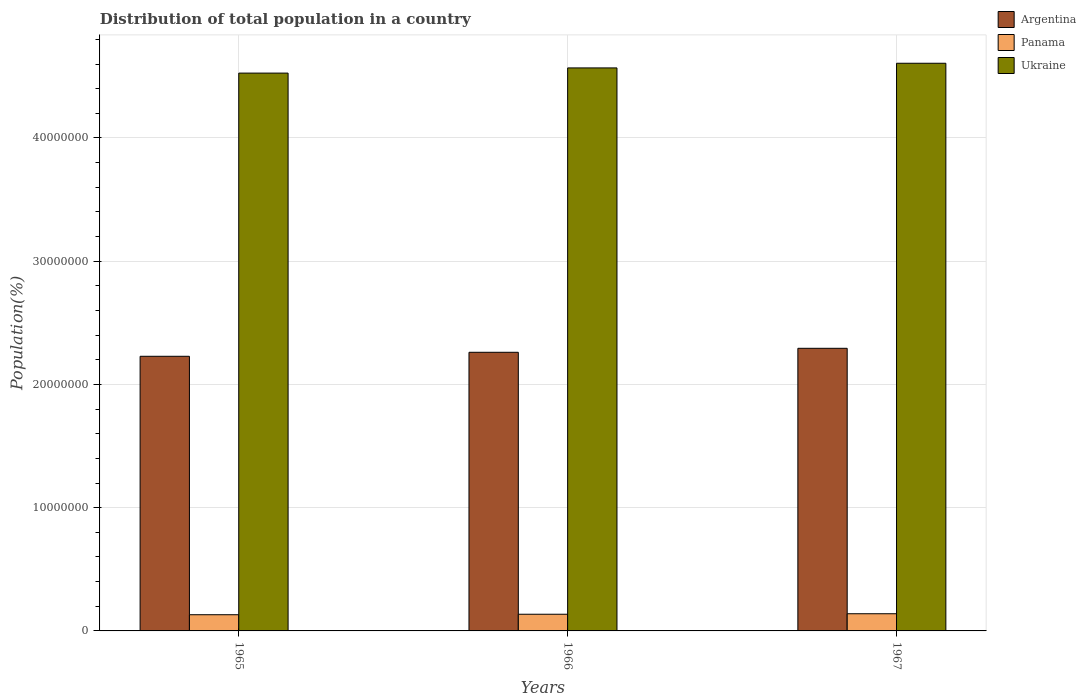How many groups of bars are there?
Provide a succinct answer. 3. How many bars are there on the 2nd tick from the left?
Keep it short and to the point. 3. What is the label of the 1st group of bars from the left?
Your answer should be compact. 1965. What is the population of in Ukraine in 1966?
Give a very brief answer. 4.57e+07. Across all years, what is the maximum population of in Argentina?
Your response must be concise. 2.29e+07. Across all years, what is the minimum population of in Panama?
Offer a very short reply. 1.31e+06. In which year was the population of in Ukraine maximum?
Give a very brief answer. 1967. In which year was the population of in Argentina minimum?
Your answer should be very brief. 1965. What is the total population of in Ukraine in the graph?
Offer a terse response. 1.37e+08. What is the difference between the population of in Ukraine in 1966 and that in 1967?
Give a very brief answer. -3.78e+05. What is the difference between the population of in Ukraine in 1965 and the population of in Panama in 1967?
Your response must be concise. 4.39e+07. What is the average population of in Panama per year?
Give a very brief answer. 1.35e+06. In the year 1967, what is the difference between the population of in Argentina and population of in Panama?
Your response must be concise. 2.15e+07. What is the ratio of the population of in Panama in 1966 to that in 1967?
Provide a short and direct response. 0.97. What is the difference between the highest and the second highest population of in Panama?
Provide a short and direct response. 4.00e+04. What is the difference between the highest and the lowest population of in Panama?
Keep it short and to the point. 7.92e+04. In how many years, is the population of in Argentina greater than the average population of in Argentina taken over all years?
Ensure brevity in your answer.  2. Is the sum of the population of in Argentina in 1966 and 1967 greater than the maximum population of in Panama across all years?
Provide a succinct answer. Yes. What does the 3rd bar from the right in 1967 represents?
Provide a short and direct response. Argentina. How many bars are there?
Your response must be concise. 9. Are all the bars in the graph horizontal?
Give a very brief answer. No. What is the difference between two consecutive major ticks on the Y-axis?
Offer a very short reply. 1.00e+07. Are the values on the major ticks of Y-axis written in scientific E-notation?
Keep it short and to the point. No. Does the graph contain any zero values?
Provide a succinct answer. No. Where does the legend appear in the graph?
Ensure brevity in your answer.  Top right. How many legend labels are there?
Provide a succinct answer. 3. How are the legend labels stacked?
Offer a terse response. Vertical. What is the title of the graph?
Your answer should be compact. Distribution of total population in a country. Does "Oman" appear as one of the legend labels in the graph?
Your answer should be very brief. No. What is the label or title of the X-axis?
Offer a very short reply. Years. What is the label or title of the Y-axis?
Offer a terse response. Population(%). What is the Population(%) in Argentina in 1965?
Your answer should be very brief. 2.23e+07. What is the Population(%) in Panama in 1965?
Provide a succinct answer. 1.31e+06. What is the Population(%) in Ukraine in 1965?
Provide a short and direct response. 4.53e+07. What is the Population(%) in Argentina in 1966?
Offer a very short reply. 2.26e+07. What is the Population(%) of Panama in 1966?
Ensure brevity in your answer.  1.35e+06. What is the Population(%) in Ukraine in 1966?
Your answer should be very brief. 4.57e+07. What is the Population(%) of Argentina in 1967?
Your answer should be very brief. 2.29e+07. What is the Population(%) of Panama in 1967?
Give a very brief answer. 1.39e+06. What is the Population(%) in Ukraine in 1967?
Your answer should be compact. 4.61e+07. Across all years, what is the maximum Population(%) in Argentina?
Provide a short and direct response. 2.29e+07. Across all years, what is the maximum Population(%) in Panama?
Ensure brevity in your answer.  1.39e+06. Across all years, what is the maximum Population(%) in Ukraine?
Offer a terse response. 4.61e+07. Across all years, what is the minimum Population(%) in Argentina?
Make the answer very short. 2.23e+07. Across all years, what is the minimum Population(%) of Panama?
Ensure brevity in your answer.  1.31e+06. Across all years, what is the minimum Population(%) of Ukraine?
Offer a very short reply. 4.53e+07. What is the total Population(%) in Argentina in the graph?
Offer a terse response. 6.78e+07. What is the total Population(%) of Panama in the graph?
Make the answer very short. 4.06e+06. What is the total Population(%) in Ukraine in the graph?
Provide a succinct answer. 1.37e+08. What is the difference between the Population(%) in Argentina in 1965 and that in 1966?
Offer a terse response. -3.25e+05. What is the difference between the Population(%) in Panama in 1965 and that in 1966?
Ensure brevity in your answer.  -3.92e+04. What is the difference between the Population(%) of Ukraine in 1965 and that in 1966?
Offer a terse response. -4.20e+05. What is the difference between the Population(%) of Argentina in 1965 and that in 1967?
Ensure brevity in your answer.  -6.49e+05. What is the difference between the Population(%) in Panama in 1965 and that in 1967?
Provide a succinct answer. -7.92e+04. What is the difference between the Population(%) of Ukraine in 1965 and that in 1967?
Your response must be concise. -7.99e+05. What is the difference between the Population(%) of Argentina in 1966 and that in 1967?
Your answer should be very brief. -3.23e+05. What is the difference between the Population(%) in Panama in 1966 and that in 1967?
Your response must be concise. -4.00e+04. What is the difference between the Population(%) in Ukraine in 1966 and that in 1967?
Give a very brief answer. -3.78e+05. What is the difference between the Population(%) in Argentina in 1965 and the Population(%) in Panama in 1966?
Your response must be concise. 2.09e+07. What is the difference between the Population(%) of Argentina in 1965 and the Population(%) of Ukraine in 1966?
Provide a succinct answer. -2.34e+07. What is the difference between the Population(%) in Panama in 1965 and the Population(%) in Ukraine in 1966?
Provide a succinct answer. -4.44e+07. What is the difference between the Population(%) in Argentina in 1965 and the Population(%) in Panama in 1967?
Provide a succinct answer. 2.09e+07. What is the difference between the Population(%) in Argentina in 1965 and the Population(%) in Ukraine in 1967?
Ensure brevity in your answer.  -2.38e+07. What is the difference between the Population(%) of Panama in 1965 and the Population(%) of Ukraine in 1967?
Give a very brief answer. -4.47e+07. What is the difference between the Population(%) of Argentina in 1966 and the Population(%) of Panama in 1967?
Ensure brevity in your answer.  2.12e+07. What is the difference between the Population(%) in Argentina in 1966 and the Population(%) in Ukraine in 1967?
Ensure brevity in your answer.  -2.35e+07. What is the difference between the Population(%) in Panama in 1966 and the Population(%) in Ukraine in 1967?
Your response must be concise. -4.47e+07. What is the average Population(%) in Argentina per year?
Your answer should be compact. 2.26e+07. What is the average Population(%) of Panama per year?
Provide a short and direct response. 1.35e+06. What is the average Population(%) in Ukraine per year?
Offer a very short reply. 4.57e+07. In the year 1965, what is the difference between the Population(%) of Argentina and Population(%) of Panama?
Your answer should be compact. 2.10e+07. In the year 1965, what is the difference between the Population(%) of Argentina and Population(%) of Ukraine?
Your answer should be compact. -2.30e+07. In the year 1965, what is the difference between the Population(%) of Panama and Population(%) of Ukraine?
Your answer should be compact. -4.39e+07. In the year 1966, what is the difference between the Population(%) in Argentina and Population(%) in Panama?
Your answer should be compact. 2.13e+07. In the year 1966, what is the difference between the Population(%) of Argentina and Population(%) of Ukraine?
Offer a very short reply. -2.31e+07. In the year 1966, what is the difference between the Population(%) in Panama and Population(%) in Ukraine?
Ensure brevity in your answer.  -4.43e+07. In the year 1967, what is the difference between the Population(%) in Argentina and Population(%) in Panama?
Give a very brief answer. 2.15e+07. In the year 1967, what is the difference between the Population(%) of Argentina and Population(%) of Ukraine?
Give a very brief answer. -2.31e+07. In the year 1967, what is the difference between the Population(%) in Panama and Population(%) in Ukraine?
Your answer should be compact. -4.47e+07. What is the ratio of the Population(%) in Argentina in 1965 to that in 1966?
Ensure brevity in your answer.  0.99. What is the ratio of the Population(%) of Panama in 1965 to that in 1966?
Your answer should be very brief. 0.97. What is the ratio of the Population(%) in Argentina in 1965 to that in 1967?
Provide a short and direct response. 0.97. What is the ratio of the Population(%) of Panama in 1965 to that in 1967?
Give a very brief answer. 0.94. What is the ratio of the Population(%) of Ukraine in 1965 to that in 1967?
Provide a succinct answer. 0.98. What is the ratio of the Population(%) in Argentina in 1966 to that in 1967?
Make the answer very short. 0.99. What is the ratio of the Population(%) in Panama in 1966 to that in 1967?
Your answer should be very brief. 0.97. What is the difference between the highest and the second highest Population(%) of Argentina?
Offer a terse response. 3.23e+05. What is the difference between the highest and the second highest Population(%) of Panama?
Give a very brief answer. 4.00e+04. What is the difference between the highest and the second highest Population(%) in Ukraine?
Make the answer very short. 3.78e+05. What is the difference between the highest and the lowest Population(%) of Argentina?
Make the answer very short. 6.49e+05. What is the difference between the highest and the lowest Population(%) of Panama?
Your answer should be very brief. 7.92e+04. What is the difference between the highest and the lowest Population(%) in Ukraine?
Make the answer very short. 7.99e+05. 